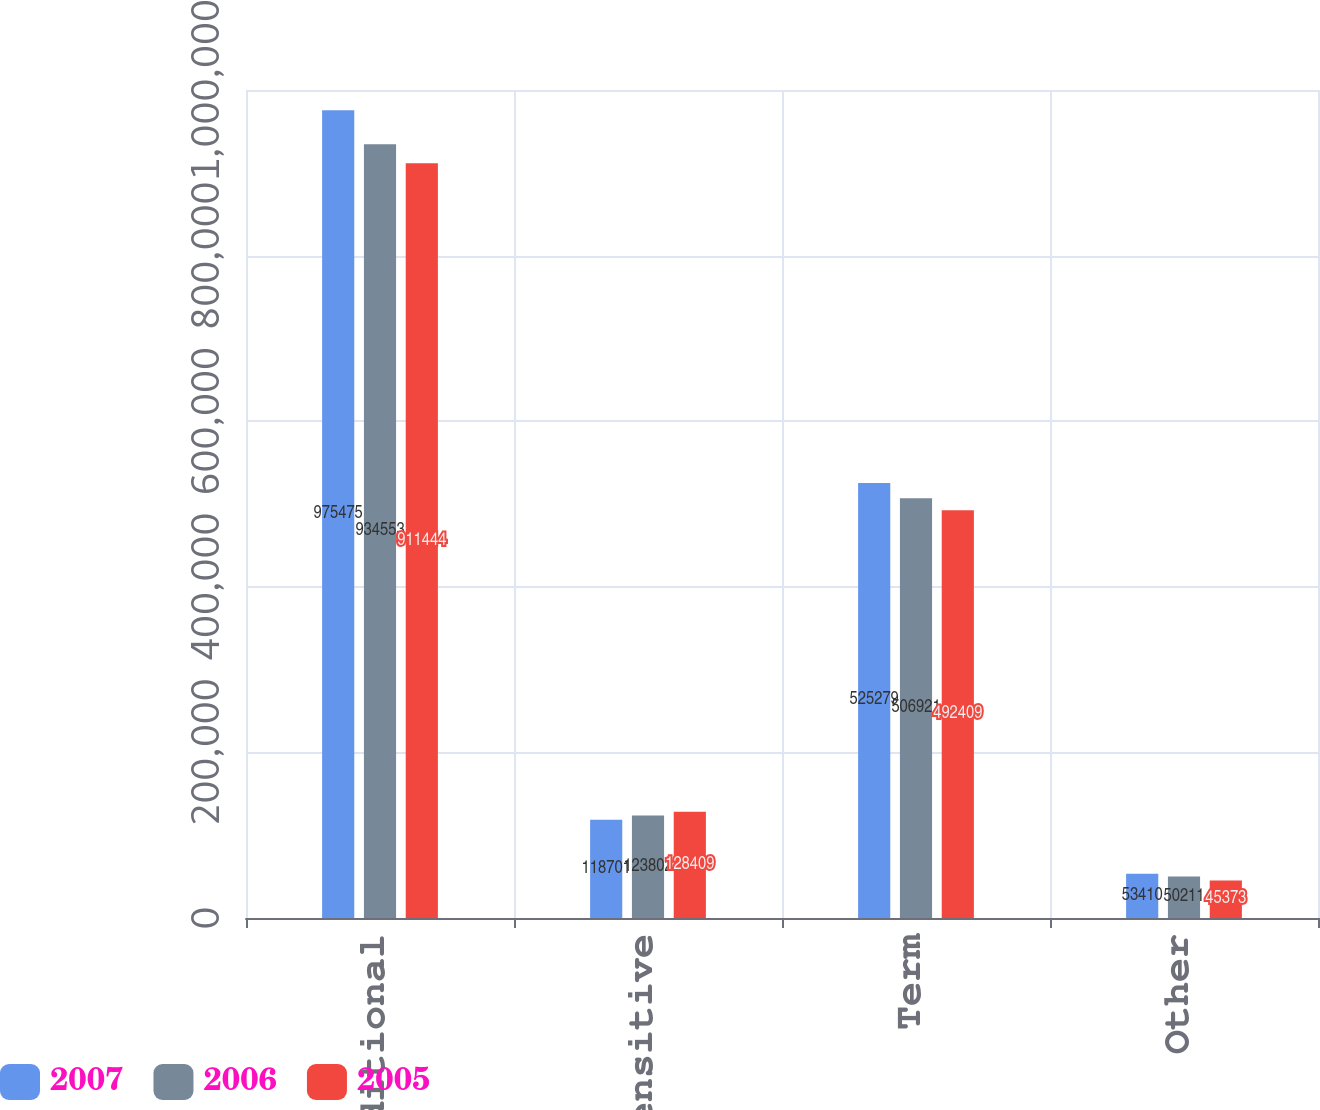Convert chart to OTSL. <chart><loc_0><loc_0><loc_500><loc_500><stacked_bar_chart><ecel><fcel>Traditional<fcel>Interest-sensitive<fcel>Term<fcel>Other<nl><fcel>2007<fcel>975475<fcel>118701<fcel>525279<fcel>53410<nl><fcel>2006<fcel>934553<fcel>123802<fcel>506921<fcel>50211<nl><fcel>2005<fcel>911444<fcel>128409<fcel>492409<fcel>45373<nl></chart> 